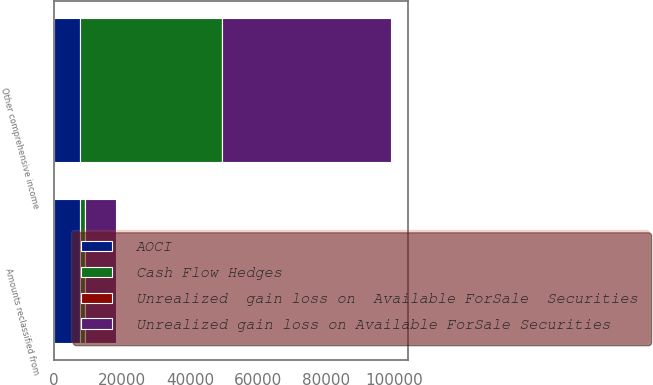Convert chart to OTSL. <chart><loc_0><loc_0><loc_500><loc_500><stacked_bar_chart><ecel><fcel>Other comprehensive income<fcel>Amounts reclassified from<nl><fcel>Unrealized gain loss on Available ForSale Securities<fcel>49524<fcel>9180<nl><fcel>AOCI<fcel>7752<fcel>7752<nl><fcel>Cash Flow Hedges<fcel>41772<fcel>1428<nl><fcel>Unrealized  gain loss on  Available ForSale  Securities<fcel>13<fcel>13<nl></chart> 